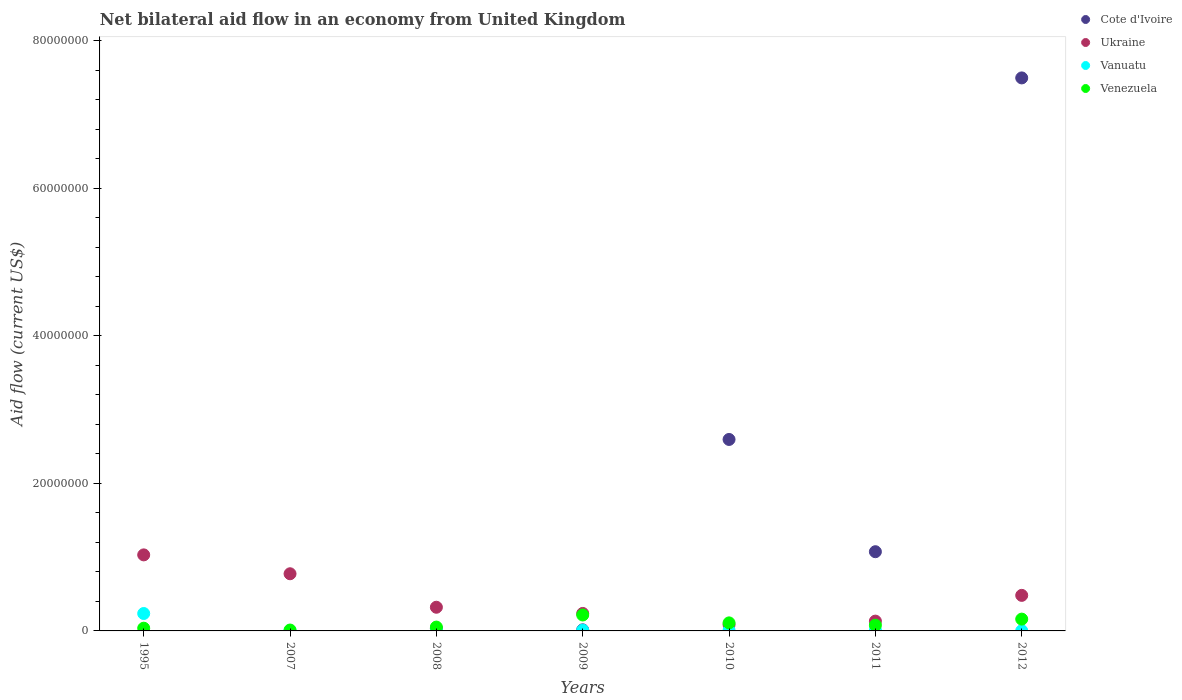How many different coloured dotlines are there?
Offer a terse response. 4. What is the net bilateral aid flow in Venezuela in 2009?
Make the answer very short. 2.16e+06. Across all years, what is the maximum net bilateral aid flow in Ukraine?
Your answer should be compact. 1.03e+07. In which year was the net bilateral aid flow in Cote d'Ivoire maximum?
Ensure brevity in your answer.  2012. What is the total net bilateral aid flow in Venezuela in the graph?
Give a very brief answer. 6.64e+06. What is the difference between the net bilateral aid flow in Venezuela in 2007 and that in 2009?
Offer a terse response. -2.04e+06. What is the difference between the net bilateral aid flow in Vanuatu in 1995 and the net bilateral aid flow in Ukraine in 2012?
Offer a terse response. -2.46e+06. What is the average net bilateral aid flow in Venezuela per year?
Your answer should be very brief. 9.49e+05. In the year 1995, what is the difference between the net bilateral aid flow in Venezuela and net bilateral aid flow in Ukraine?
Offer a very short reply. -9.94e+06. In how many years, is the net bilateral aid flow in Cote d'Ivoire greater than 56000000 US$?
Provide a short and direct response. 1. What is the ratio of the net bilateral aid flow in Venezuela in 1995 to that in 2011?
Provide a succinct answer. 0.47. What is the difference between the highest and the second highest net bilateral aid flow in Venezuela?
Your answer should be very brief. 5.60e+05. What is the difference between the highest and the lowest net bilateral aid flow in Vanuatu?
Your answer should be very brief. 2.33e+06. In how many years, is the net bilateral aid flow in Cote d'Ivoire greater than the average net bilateral aid flow in Cote d'Ivoire taken over all years?
Ensure brevity in your answer.  2. Is the sum of the net bilateral aid flow in Vanuatu in 2009 and 2012 greater than the maximum net bilateral aid flow in Cote d'Ivoire across all years?
Keep it short and to the point. No. Is it the case that in every year, the sum of the net bilateral aid flow in Cote d'Ivoire and net bilateral aid flow in Vanuatu  is greater than the sum of net bilateral aid flow in Ukraine and net bilateral aid flow in Venezuela?
Keep it short and to the point. No. Is the net bilateral aid flow in Ukraine strictly less than the net bilateral aid flow in Venezuela over the years?
Offer a terse response. No. How many dotlines are there?
Provide a succinct answer. 4. How many years are there in the graph?
Offer a terse response. 7. What is the difference between two consecutive major ticks on the Y-axis?
Your answer should be compact. 2.00e+07. Are the values on the major ticks of Y-axis written in scientific E-notation?
Provide a short and direct response. No. How many legend labels are there?
Ensure brevity in your answer.  4. How are the legend labels stacked?
Give a very brief answer. Vertical. What is the title of the graph?
Ensure brevity in your answer.  Net bilateral aid flow in an economy from United Kingdom. Does "Macedonia" appear as one of the legend labels in the graph?
Your answer should be compact. No. What is the label or title of the X-axis?
Give a very brief answer. Years. What is the label or title of the Y-axis?
Give a very brief answer. Aid flow (current US$). What is the Aid flow (current US$) of Ukraine in 1995?
Provide a short and direct response. 1.03e+07. What is the Aid flow (current US$) in Vanuatu in 1995?
Provide a short and direct response. 2.36e+06. What is the Aid flow (current US$) of Venezuela in 1995?
Your answer should be very brief. 3.70e+05. What is the Aid flow (current US$) in Cote d'Ivoire in 2007?
Your answer should be compact. 0. What is the Aid flow (current US$) in Ukraine in 2007?
Your answer should be very brief. 7.75e+06. What is the Aid flow (current US$) in Vanuatu in 2007?
Ensure brevity in your answer.  4.00e+04. What is the Aid flow (current US$) of Venezuela in 2007?
Ensure brevity in your answer.  1.20e+05. What is the Aid flow (current US$) in Ukraine in 2008?
Make the answer very short. 3.21e+06. What is the Aid flow (current US$) in Vanuatu in 2008?
Offer a very short reply. 9.00e+04. What is the Aid flow (current US$) of Venezuela in 2008?
Offer a very short reply. 5.20e+05. What is the Aid flow (current US$) in Cote d'Ivoire in 2009?
Keep it short and to the point. 1.50e+05. What is the Aid flow (current US$) in Ukraine in 2009?
Your answer should be compact. 2.37e+06. What is the Aid flow (current US$) of Vanuatu in 2009?
Ensure brevity in your answer.  1.00e+05. What is the Aid flow (current US$) in Venezuela in 2009?
Make the answer very short. 2.16e+06. What is the Aid flow (current US$) in Cote d'Ivoire in 2010?
Keep it short and to the point. 2.60e+07. What is the Aid flow (current US$) of Ukraine in 2010?
Your answer should be very brief. 8.40e+05. What is the Aid flow (current US$) of Vanuatu in 2010?
Keep it short and to the point. 9.00e+04. What is the Aid flow (current US$) of Venezuela in 2010?
Your answer should be very brief. 1.09e+06. What is the Aid flow (current US$) of Cote d'Ivoire in 2011?
Provide a succinct answer. 1.07e+07. What is the Aid flow (current US$) of Ukraine in 2011?
Ensure brevity in your answer.  1.33e+06. What is the Aid flow (current US$) of Vanuatu in 2011?
Your answer should be compact. 1.10e+05. What is the Aid flow (current US$) of Venezuela in 2011?
Provide a succinct answer. 7.80e+05. What is the Aid flow (current US$) in Cote d'Ivoire in 2012?
Offer a very short reply. 7.50e+07. What is the Aid flow (current US$) in Ukraine in 2012?
Ensure brevity in your answer.  4.82e+06. What is the Aid flow (current US$) in Vanuatu in 2012?
Your answer should be compact. 3.00e+04. What is the Aid flow (current US$) of Venezuela in 2012?
Your response must be concise. 1.60e+06. Across all years, what is the maximum Aid flow (current US$) of Cote d'Ivoire?
Your answer should be compact. 7.50e+07. Across all years, what is the maximum Aid flow (current US$) of Ukraine?
Offer a very short reply. 1.03e+07. Across all years, what is the maximum Aid flow (current US$) in Vanuatu?
Your response must be concise. 2.36e+06. Across all years, what is the maximum Aid flow (current US$) of Venezuela?
Make the answer very short. 2.16e+06. Across all years, what is the minimum Aid flow (current US$) of Ukraine?
Give a very brief answer. 8.40e+05. Across all years, what is the minimum Aid flow (current US$) of Venezuela?
Your response must be concise. 1.20e+05. What is the total Aid flow (current US$) in Cote d'Ivoire in the graph?
Keep it short and to the point. 1.12e+08. What is the total Aid flow (current US$) in Ukraine in the graph?
Keep it short and to the point. 3.06e+07. What is the total Aid flow (current US$) in Vanuatu in the graph?
Give a very brief answer. 2.82e+06. What is the total Aid flow (current US$) in Venezuela in the graph?
Provide a short and direct response. 6.64e+06. What is the difference between the Aid flow (current US$) of Ukraine in 1995 and that in 2007?
Ensure brevity in your answer.  2.56e+06. What is the difference between the Aid flow (current US$) in Vanuatu in 1995 and that in 2007?
Offer a terse response. 2.32e+06. What is the difference between the Aid flow (current US$) in Venezuela in 1995 and that in 2007?
Provide a short and direct response. 2.50e+05. What is the difference between the Aid flow (current US$) of Ukraine in 1995 and that in 2008?
Your answer should be very brief. 7.10e+06. What is the difference between the Aid flow (current US$) in Vanuatu in 1995 and that in 2008?
Your answer should be very brief. 2.27e+06. What is the difference between the Aid flow (current US$) in Ukraine in 1995 and that in 2009?
Your response must be concise. 7.94e+06. What is the difference between the Aid flow (current US$) in Vanuatu in 1995 and that in 2009?
Provide a short and direct response. 2.26e+06. What is the difference between the Aid flow (current US$) of Venezuela in 1995 and that in 2009?
Offer a very short reply. -1.79e+06. What is the difference between the Aid flow (current US$) in Ukraine in 1995 and that in 2010?
Provide a succinct answer. 9.47e+06. What is the difference between the Aid flow (current US$) in Vanuatu in 1995 and that in 2010?
Provide a short and direct response. 2.27e+06. What is the difference between the Aid flow (current US$) of Venezuela in 1995 and that in 2010?
Keep it short and to the point. -7.20e+05. What is the difference between the Aid flow (current US$) in Ukraine in 1995 and that in 2011?
Offer a terse response. 8.98e+06. What is the difference between the Aid flow (current US$) in Vanuatu in 1995 and that in 2011?
Keep it short and to the point. 2.25e+06. What is the difference between the Aid flow (current US$) of Venezuela in 1995 and that in 2011?
Offer a very short reply. -4.10e+05. What is the difference between the Aid flow (current US$) in Ukraine in 1995 and that in 2012?
Offer a very short reply. 5.49e+06. What is the difference between the Aid flow (current US$) of Vanuatu in 1995 and that in 2012?
Offer a terse response. 2.33e+06. What is the difference between the Aid flow (current US$) of Venezuela in 1995 and that in 2012?
Offer a very short reply. -1.23e+06. What is the difference between the Aid flow (current US$) in Ukraine in 2007 and that in 2008?
Offer a very short reply. 4.54e+06. What is the difference between the Aid flow (current US$) in Vanuatu in 2007 and that in 2008?
Make the answer very short. -5.00e+04. What is the difference between the Aid flow (current US$) of Venezuela in 2007 and that in 2008?
Offer a very short reply. -4.00e+05. What is the difference between the Aid flow (current US$) of Ukraine in 2007 and that in 2009?
Your answer should be compact. 5.38e+06. What is the difference between the Aid flow (current US$) of Vanuatu in 2007 and that in 2009?
Offer a very short reply. -6.00e+04. What is the difference between the Aid flow (current US$) of Venezuela in 2007 and that in 2009?
Your response must be concise. -2.04e+06. What is the difference between the Aid flow (current US$) of Ukraine in 2007 and that in 2010?
Your response must be concise. 6.91e+06. What is the difference between the Aid flow (current US$) of Venezuela in 2007 and that in 2010?
Your answer should be very brief. -9.70e+05. What is the difference between the Aid flow (current US$) in Ukraine in 2007 and that in 2011?
Provide a succinct answer. 6.42e+06. What is the difference between the Aid flow (current US$) of Vanuatu in 2007 and that in 2011?
Provide a succinct answer. -7.00e+04. What is the difference between the Aid flow (current US$) of Venezuela in 2007 and that in 2011?
Offer a terse response. -6.60e+05. What is the difference between the Aid flow (current US$) of Ukraine in 2007 and that in 2012?
Offer a very short reply. 2.93e+06. What is the difference between the Aid flow (current US$) of Venezuela in 2007 and that in 2012?
Make the answer very short. -1.48e+06. What is the difference between the Aid flow (current US$) of Ukraine in 2008 and that in 2009?
Ensure brevity in your answer.  8.40e+05. What is the difference between the Aid flow (current US$) in Venezuela in 2008 and that in 2009?
Your response must be concise. -1.64e+06. What is the difference between the Aid flow (current US$) of Cote d'Ivoire in 2008 and that in 2010?
Your response must be concise. -2.56e+07. What is the difference between the Aid flow (current US$) in Ukraine in 2008 and that in 2010?
Ensure brevity in your answer.  2.37e+06. What is the difference between the Aid flow (current US$) of Vanuatu in 2008 and that in 2010?
Make the answer very short. 0. What is the difference between the Aid flow (current US$) in Venezuela in 2008 and that in 2010?
Provide a short and direct response. -5.70e+05. What is the difference between the Aid flow (current US$) in Cote d'Ivoire in 2008 and that in 2011?
Give a very brief answer. -1.04e+07. What is the difference between the Aid flow (current US$) in Ukraine in 2008 and that in 2011?
Make the answer very short. 1.88e+06. What is the difference between the Aid flow (current US$) in Vanuatu in 2008 and that in 2011?
Your answer should be compact. -2.00e+04. What is the difference between the Aid flow (current US$) of Venezuela in 2008 and that in 2011?
Keep it short and to the point. -2.60e+05. What is the difference between the Aid flow (current US$) of Cote d'Ivoire in 2008 and that in 2012?
Offer a very short reply. -7.46e+07. What is the difference between the Aid flow (current US$) of Ukraine in 2008 and that in 2012?
Provide a succinct answer. -1.61e+06. What is the difference between the Aid flow (current US$) in Venezuela in 2008 and that in 2012?
Provide a succinct answer. -1.08e+06. What is the difference between the Aid flow (current US$) in Cote d'Ivoire in 2009 and that in 2010?
Your answer should be very brief. -2.58e+07. What is the difference between the Aid flow (current US$) in Ukraine in 2009 and that in 2010?
Ensure brevity in your answer.  1.53e+06. What is the difference between the Aid flow (current US$) in Vanuatu in 2009 and that in 2010?
Offer a very short reply. 10000. What is the difference between the Aid flow (current US$) of Venezuela in 2009 and that in 2010?
Offer a terse response. 1.07e+06. What is the difference between the Aid flow (current US$) of Cote d'Ivoire in 2009 and that in 2011?
Give a very brief answer. -1.06e+07. What is the difference between the Aid flow (current US$) in Ukraine in 2009 and that in 2011?
Your response must be concise. 1.04e+06. What is the difference between the Aid flow (current US$) in Vanuatu in 2009 and that in 2011?
Your answer should be compact. -10000. What is the difference between the Aid flow (current US$) of Venezuela in 2009 and that in 2011?
Provide a succinct answer. 1.38e+06. What is the difference between the Aid flow (current US$) in Cote d'Ivoire in 2009 and that in 2012?
Your answer should be compact. -7.48e+07. What is the difference between the Aid flow (current US$) of Ukraine in 2009 and that in 2012?
Offer a terse response. -2.45e+06. What is the difference between the Aid flow (current US$) in Vanuatu in 2009 and that in 2012?
Ensure brevity in your answer.  7.00e+04. What is the difference between the Aid flow (current US$) of Venezuela in 2009 and that in 2012?
Keep it short and to the point. 5.60e+05. What is the difference between the Aid flow (current US$) in Cote d'Ivoire in 2010 and that in 2011?
Provide a succinct answer. 1.52e+07. What is the difference between the Aid flow (current US$) in Ukraine in 2010 and that in 2011?
Provide a succinct answer. -4.90e+05. What is the difference between the Aid flow (current US$) in Cote d'Ivoire in 2010 and that in 2012?
Ensure brevity in your answer.  -4.90e+07. What is the difference between the Aid flow (current US$) of Ukraine in 2010 and that in 2012?
Provide a short and direct response. -3.98e+06. What is the difference between the Aid flow (current US$) of Venezuela in 2010 and that in 2012?
Offer a very short reply. -5.10e+05. What is the difference between the Aid flow (current US$) of Cote d'Ivoire in 2011 and that in 2012?
Provide a short and direct response. -6.42e+07. What is the difference between the Aid flow (current US$) of Ukraine in 2011 and that in 2012?
Your response must be concise. -3.49e+06. What is the difference between the Aid flow (current US$) in Vanuatu in 2011 and that in 2012?
Give a very brief answer. 8.00e+04. What is the difference between the Aid flow (current US$) in Venezuela in 2011 and that in 2012?
Offer a terse response. -8.20e+05. What is the difference between the Aid flow (current US$) in Ukraine in 1995 and the Aid flow (current US$) in Vanuatu in 2007?
Your response must be concise. 1.03e+07. What is the difference between the Aid flow (current US$) of Ukraine in 1995 and the Aid flow (current US$) of Venezuela in 2007?
Your answer should be compact. 1.02e+07. What is the difference between the Aid flow (current US$) in Vanuatu in 1995 and the Aid flow (current US$) in Venezuela in 2007?
Keep it short and to the point. 2.24e+06. What is the difference between the Aid flow (current US$) in Ukraine in 1995 and the Aid flow (current US$) in Vanuatu in 2008?
Ensure brevity in your answer.  1.02e+07. What is the difference between the Aid flow (current US$) in Ukraine in 1995 and the Aid flow (current US$) in Venezuela in 2008?
Your answer should be compact. 9.79e+06. What is the difference between the Aid flow (current US$) of Vanuatu in 1995 and the Aid flow (current US$) of Venezuela in 2008?
Offer a very short reply. 1.84e+06. What is the difference between the Aid flow (current US$) in Ukraine in 1995 and the Aid flow (current US$) in Vanuatu in 2009?
Give a very brief answer. 1.02e+07. What is the difference between the Aid flow (current US$) in Ukraine in 1995 and the Aid flow (current US$) in Venezuela in 2009?
Give a very brief answer. 8.15e+06. What is the difference between the Aid flow (current US$) of Vanuatu in 1995 and the Aid flow (current US$) of Venezuela in 2009?
Offer a terse response. 2.00e+05. What is the difference between the Aid flow (current US$) of Ukraine in 1995 and the Aid flow (current US$) of Vanuatu in 2010?
Your response must be concise. 1.02e+07. What is the difference between the Aid flow (current US$) in Ukraine in 1995 and the Aid flow (current US$) in Venezuela in 2010?
Your answer should be very brief. 9.22e+06. What is the difference between the Aid flow (current US$) in Vanuatu in 1995 and the Aid flow (current US$) in Venezuela in 2010?
Keep it short and to the point. 1.27e+06. What is the difference between the Aid flow (current US$) in Ukraine in 1995 and the Aid flow (current US$) in Vanuatu in 2011?
Make the answer very short. 1.02e+07. What is the difference between the Aid flow (current US$) of Ukraine in 1995 and the Aid flow (current US$) of Venezuela in 2011?
Your response must be concise. 9.53e+06. What is the difference between the Aid flow (current US$) in Vanuatu in 1995 and the Aid flow (current US$) in Venezuela in 2011?
Your response must be concise. 1.58e+06. What is the difference between the Aid flow (current US$) of Ukraine in 1995 and the Aid flow (current US$) of Vanuatu in 2012?
Make the answer very short. 1.03e+07. What is the difference between the Aid flow (current US$) in Ukraine in 1995 and the Aid flow (current US$) in Venezuela in 2012?
Provide a short and direct response. 8.71e+06. What is the difference between the Aid flow (current US$) in Vanuatu in 1995 and the Aid flow (current US$) in Venezuela in 2012?
Offer a very short reply. 7.60e+05. What is the difference between the Aid flow (current US$) in Ukraine in 2007 and the Aid flow (current US$) in Vanuatu in 2008?
Your answer should be compact. 7.66e+06. What is the difference between the Aid flow (current US$) of Ukraine in 2007 and the Aid flow (current US$) of Venezuela in 2008?
Keep it short and to the point. 7.23e+06. What is the difference between the Aid flow (current US$) in Vanuatu in 2007 and the Aid flow (current US$) in Venezuela in 2008?
Provide a short and direct response. -4.80e+05. What is the difference between the Aid flow (current US$) of Ukraine in 2007 and the Aid flow (current US$) of Vanuatu in 2009?
Provide a short and direct response. 7.65e+06. What is the difference between the Aid flow (current US$) of Ukraine in 2007 and the Aid flow (current US$) of Venezuela in 2009?
Offer a very short reply. 5.59e+06. What is the difference between the Aid flow (current US$) in Vanuatu in 2007 and the Aid flow (current US$) in Venezuela in 2009?
Offer a terse response. -2.12e+06. What is the difference between the Aid flow (current US$) of Ukraine in 2007 and the Aid flow (current US$) of Vanuatu in 2010?
Provide a succinct answer. 7.66e+06. What is the difference between the Aid flow (current US$) of Ukraine in 2007 and the Aid flow (current US$) of Venezuela in 2010?
Your response must be concise. 6.66e+06. What is the difference between the Aid flow (current US$) of Vanuatu in 2007 and the Aid flow (current US$) of Venezuela in 2010?
Your answer should be very brief. -1.05e+06. What is the difference between the Aid flow (current US$) in Ukraine in 2007 and the Aid flow (current US$) in Vanuatu in 2011?
Provide a succinct answer. 7.64e+06. What is the difference between the Aid flow (current US$) in Ukraine in 2007 and the Aid flow (current US$) in Venezuela in 2011?
Your response must be concise. 6.97e+06. What is the difference between the Aid flow (current US$) of Vanuatu in 2007 and the Aid flow (current US$) of Venezuela in 2011?
Offer a very short reply. -7.40e+05. What is the difference between the Aid flow (current US$) of Ukraine in 2007 and the Aid flow (current US$) of Vanuatu in 2012?
Give a very brief answer. 7.72e+06. What is the difference between the Aid flow (current US$) in Ukraine in 2007 and the Aid flow (current US$) in Venezuela in 2012?
Your answer should be very brief. 6.15e+06. What is the difference between the Aid flow (current US$) of Vanuatu in 2007 and the Aid flow (current US$) of Venezuela in 2012?
Your answer should be compact. -1.56e+06. What is the difference between the Aid flow (current US$) of Cote d'Ivoire in 2008 and the Aid flow (current US$) of Ukraine in 2009?
Your response must be concise. -2.03e+06. What is the difference between the Aid flow (current US$) of Cote d'Ivoire in 2008 and the Aid flow (current US$) of Venezuela in 2009?
Your answer should be compact. -1.82e+06. What is the difference between the Aid flow (current US$) in Ukraine in 2008 and the Aid flow (current US$) in Vanuatu in 2009?
Ensure brevity in your answer.  3.11e+06. What is the difference between the Aid flow (current US$) of Ukraine in 2008 and the Aid flow (current US$) of Venezuela in 2009?
Your response must be concise. 1.05e+06. What is the difference between the Aid flow (current US$) of Vanuatu in 2008 and the Aid flow (current US$) of Venezuela in 2009?
Your answer should be very brief. -2.07e+06. What is the difference between the Aid flow (current US$) in Cote d'Ivoire in 2008 and the Aid flow (current US$) in Ukraine in 2010?
Ensure brevity in your answer.  -5.00e+05. What is the difference between the Aid flow (current US$) of Cote d'Ivoire in 2008 and the Aid flow (current US$) of Venezuela in 2010?
Your answer should be compact. -7.50e+05. What is the difference between the Aid flow (current US$) of Ukraine in 2008 and the Aid flow (current US$) of Vanuatu in 2010?
Offer a terse response. 3.12e+06. What is the difference between the Aid flow (current US$) of Ukraine in 2008 and the Aid flow (current US$) of Venezuela in 2010?
Provide a short and direct response. 2.12e+06. What is the difference between the Aid flow (current US$) in Vanuatu in 2008 and the Aid flow (current US$) in Venezuela in 2010?
Provide a short and direct response. -1.00e+06. What is the difference between the Aid flow (current US$) in Cote d'Ivoire in 2008 and the Aid flow (current US$) in Ukraine in 2011?
Offer a very short reply. -9.90e+05. What is the difference between the Aid flow (current US$) in Cote d'Ivoire in 2008 and the Aid flow (current US$) in Venezuela in 2011?
Offer a terse response. -4.40e+05. What is the difference between the Aid flow (current US$) of Ukraine in 2008 and the Aid flow (current US$) of Vanuatu in 2011?
Make the answer very short. 3.10e+06. What is the difference between the Aid flow (current US$) of Ukraine in 2008 and the Aid flow (current US$) of Venezuela in 2011?
Provide a short and direct response. 2.43e+06. What is the difference between the Aid flow (current US$) of Vanuatu in 2008 and the Aid flow (current US$) of Venezuela in 2011?
Provide a short and direct response. -6.90e+05. What is the difference between the Aid flow (current US$) in Cote d'Ivoire in 2008 and the Aid flow (current US$) in Ukraine in 2012?
Keep it short and to the point. -4.48e+06. What is the difference between the Aid flow (current US$) of Cote d'Ivoire in 2008 and the Aid flow (current US$) of Venezuela in 2012?
Give a very brief answer. -1.26e+06. What is the difference between the Aid flow (current US$) in Ukraine in 2008 and the Aid flow (current US$) in Vanuatu in 2012?
Your answer should be compact. 3.18e+06. What is the difference between the Aid flow (current US$) in Ukraine in 2008 and the Aid flow (current US$) in Venezuela in 2012?
Give a very brief answer. 1.61e+06. What is the difference between the Aid flow (current US$) in Vanuatu in 2008 and the Aid flow (current US$) in Venezuela in 2012?
Give a very brief answer. -1.51e+06. What is the difference between the Aid flow (current US$) in Cote d'Ivoire in 2009 and the Aid flow (current US$) in Ukraine in 2010?
Provide a succinct answer. -6.90e+05. What is the difference between the Aid flow (current US$) of Cote d'Ivoire in 2009 and the Aid flow (current US$) of Vanuatu in 2010?
Give a very brief answer. 6.00e+04. What is the difference between the Aid flow (current US$) of Cote d'Ivoire in 2009 and the Aid flow (current US$) of Venezuela in 2010?
Offer a very short reply. -9.40e+05. What is the difference between the Aid flow (current US$) of Ukraine in 2009 and the Aid flow (current US$) of Vanuatu in 2010?
Ensure brevity in your answer.  2.28e+06. What is the difference between the Aid flow (current US$) of Ukraine in 2009 and the Aid flow (current US$) of Venezuela in 2010?
Your response must be concise. 1.28e+06. What is the difference between the Aid flow (current US$) of Vanuatu in 2009 and the Aid flow (current US$) of Venezuela in 2010?
Your answer should be compact. -9.90e+05. What is the difference between the Aid flow (current US$) of Cote d'Ivoire in 2009 and the Aid flow (current US$) of Ukraine in 2011?
Provide a succinct answer. -1.18e+06. What is the difference between the Aid flow (current US$) of Cote d'Ivoire in 2009 and the Aid flow (current US$) of Vanuatu in 2011?
Your response must be concise. 4.00e+04. What is the difference between the Aid flow (current US$) of Cote d'Ivoire in 2009 and the Aid flow (current US$) of Venezuela in 2011?
Provide a succinct answer. -6.30e+05. What is the difference between the Aid flow (current US$) in Ukraine in 2009 and the Aid flow (current US$) in Vanuatu in 2011?
Your answer should be compact. 2.26e+06. What is the difference between the Aid flow (current US$) of Ukraine in 2009 and the Aid flow (current US$) of Venezuela in 2011?
Provide a short and direct response. 1.59e+06. What is the difference between the Aid flow (current US$) of Vanuatu in 2009 and the Aid flow (current US$) of Venezuela in 2011?
Provide a succinct answer. -6.80e+05. What is the difference between the Aid flow (current US$) of Cote d'Ivoire in 2009 and the Aid flow (current US$) of Ukraine in 2012?
Your answer should be compact. -4.67e+06. What is the difference between the Aid flow (current US$) in Cote d'Ivoire in 2009 and the Aid flow (current US$) in Vanuatu in 2012?
Provide a short and direct response. 1.20e+05. What is the difference between the Aid flow (current US$) in Cote d'Ivoire in 2009 and the Aid flow (current US$) in Venezuela in 2012?
Your answer should be very brief. -1.45e+06. What is the difference between the Aid flow (current US$) in Ukraine in 2009 and the Aid flow (current US$) in Vanuatu in 2012?
Make the answer very short. 2.34e+06. What is the difference between the Aid flow (current US$) of Ukraine in 2009 and the Aid flow (current US$) of Venezuela in 2012?
Provide a succinct answer. 7.70e+05. What is the difference between the Aid flow (current US$) in Vanuatu in 2009 and the Aid flow (current US$) in Venezuela in 2012?
Your answer should be very brief. -1.50e+06. What is the difference between the Aid flow (current US$) in Cote d'Ivoire in 2010 and the Aid flow (current US$) in Ukraine in 2011?
Offer a terse response. 2.46e+07. What is the difference between the Aid flow (current US$) in Cote d'Ivoire in 2010 and the Aid flow (current US$) in Vanuatu in 2011?
Your answer should be compact. 2.58e+07. What is the difference between the Aid flow (current US$) in Cote d'Ivoire in 2010 and the Aid flow (current US$) in Venezuela in 2011?
Provide a succinct answer. 2.52e+07. What is the difference between the Aid flow (current US$) of Ukraine in 2010 and the Aid flow (current US$) of Vanuatu in 2011?
Make the answer very short. 7.30e+05. What is the difference between the Aid flow (current US$) in Vanuatu in 2010 and the Aid flow (current US$) in Venezuela in 2011?
Offer a very short reply. -6.90e+05. What is the difference between the Aid flow (current US$) of Cote d'Ivoire in 2010 and the Aid flow (current US$) of Ukraine in 2012?
Your answer should be compact. 2.11e+07. What is the difference between the Aid flow (current US$) in Cote d'Ivoire in 2010 and the Aid flow (current US$) in Vanuatu in 2012?
Offer a very short reply. 2.59e+07. What is the difference between the Aid flow (current US$) in Cote d'Ivoire in 2010 and the Aid flow (current US$) in Venezuela in 2012?
Give a very brief answer. 2.44e+07. What is the difference between the Aid flow (current US$) in Ukraine in 2010 and the Aid flow (current US$) in Vanuatu in 2012?
Provide a short and direct response. 8.10e+05. What is the difference between the Aid flow (current US$) in Ukraine in 2010 and the Aid flow (current US$) in Venezuela in 2012?
Your response must be concise. -7.60e+05. What is the difference between the Aid flow (current US$) in Vanuatu in 2010 and the Aid flow (current US$) in Venezuela in 2012?
Ensure brevity in your answer.  -1.51e+06. What is the difference between the Aid flow (current US$) in Cote d'Ivoire in 2011 and the Aid flow (current US$) in Ukraine in 2012?
Your answer should be compact. 5.92e+06. What is the difference between the Aid flow (current US$) in Cote d'Ivoire in 2011 and the Aid flow (current US$) in Vanuatu in 2012?
Offer a terse response. 1.07e+07. What is the difference between the Aid flow (current US$) in Cote d'Ivoire in 2011 and the Aid flow (current US$) in Venezuela in 2012?
Ensure brevity in your answer.  9.14e+06. What is the difference between the Aid flow (current US$) in Ukraine in 2011 and the Aid flow (current US$) in Vanuatu in 2012?
Ensure brevity in your answer.  1.30e+06. What is the difference between the Aid flow (current US$) in Vanuatu in 2011 and the Aid flow (current US$) in Venezuela in 2012?
Give a very brief answer. -1.49e+06. What is the average Aid flow (current US$) in Cote d'Ivoire per year?
Ensure brevity in your answer.  1.60e+07. What is the average Aid flow (current US$) in Ukraine per year?
Give a very brief answer. 4.38e+06. What is the average Aid flow (current US$) in Vanuatu per year?
Offer a terse response. 4.03e+05. What is the average Aid flow (current US$) in Venezuela per year?
Keep it short and to the point. 9.49e+05. In the year 1995, what is the difference between the Aid flow (current US$) of Ukraine and Aid flow (current US$) of Vanuatu?
Ensure brevity in your answer.  7.95e+06. In the year 1995, what is the difference between the Aid flow (current US$) in Ukraine and Aid flow (current US$) in Venezuela?
Provide a short and direct response. 9.94e+06. In the year 1995, what is the difference between the Aid flow (current US$) of Vanuatu and Aid flow (current US$) of Venezuela?
Offer a very short reply. 1.99e+06. In the year 2007, what is the difference between the Aid flow (current US$) of Ukraine and Aid flow (current US$) of Vanuatu?
Provide a succinct answer. 7.71e+06. In the year 2007, what is the difference between the Aid flow (current US$) in Ukraine and Aid flow (current US$) in Venezuela?
Your answer should be compact. 7.63e+06. In the year 2007, what is the difference between the Aid flow (current US$) of Vanuatu and Aid flow (current US$) of Venezuela?
Make the answer very short. -8.00e+04. In the year 2008, what is the difference between the Aid flow (current US$) of Cote d'Ivoire and Aid flow (current US$) of Ukraine?
Make the answer very short. -2.87e+06. In the year 2008, what is the difference between the Aid flow (current US$) in Cote d'Ivoire and Aid flow (current US$) in Venezuela?
Provide a short and direct response. -1.80e+05. In the year 2008, what is the difference between the Aid flow (current US$) of Ukraine and Aid flow (current US$) of Vanuatu?
Provide a succinct answer. 3.12e+06. In the year 2008, what is the difference between the Aid flow (current US$) of Ukraine and Aid flow (current US$) of Venezuela?
Offer a very short reply. 2.69e+06. In the year 2008, what is the difference between the Aid flow (current US$) in Vanuatu and Aid flow (current US$) in Venezuela?
Your answer should be compact. -4.30e+05. In the year 2009, what is the difference between the Aid flow (current US$) in Cote d'Ivoire and Aid flow (current US$) in Ukraine?
Give a very brief answer. -2.22e+06. In the year 2009, what is the difference between the Aid flow (current US$) of Cote d'Ivoire and Aid flow (current US$) of Vanuatu?
Offer a terse response. 5.00e+04. In the year 2009, what is the difference between the Aid flow (current US$) of Cote d'Ivoire and Aid flow (current US$) of Venezuela?
Give a very brief answer. -2.01e+06. In the year 2009, what is the difference between the Aid flow (current US$) of Ukraine and Aid flow (current US$) of Vanuatu?
Your answer should be very brief. 2.27e+06. In the year 2009, what is the difference between the Aid flow (current US$) of Ukraine and Aid flow (current US$) of Venezuela?
Ensure brevity in your answer.  2.10e+05. In the year 2009, what is the difference between the Aid flow (current US$) of Vanuatu and Aid flow (current US$) of Venezuela?
Your answer should be very brief. -2.06e+06. In the year 2010, what is the difference between the Aid flow (current US$) in Cote d'Ivoire and Aid flow (current US$) in Ukraine?
Your answer should be very brief. 2.51e+07. In the year 2010, what is the difference between the Aid flow (current US$) of Cote d'Ivoire and Aid flow (current US$) of Vanuatu?
Your answer should be compact. 2.59e+07. In the year 2010, what is the difference between the Aid flow (current US$) in Cote d'Ivoire and Aid flow (current US$) in Venezuela?
Your response must be concise. 2.49e+07. In the year 2010, what is the difference between the Aid flow (current US$) of Ukraine and Aid flow (current US$) of Vanuatu?
Your response must be concise. 7.50e+05. In the year 2010, what is the difference between the Aid flow (current US$) in Ukraine and Aid flow (current US$) in Venezuela?
Make the answer very short. -2.50e+05. In the year 2011, what is the difference between the Aid flow (current US$) of Cote d'Ivoire and Aid flow (current US$) of Ukraine?
Offer a very short reply. 9.41e+06. In the year 2011, what is the difference between the Aid flow (current US$) of Cote d'Ivoire and Aid flow (current US$) of Vanuatu?
Give a very brief answer. 1.06e+07. In the year 2011, what is the difference between the Aid flow (current US$) of Cote d'Ivoire and Aid flow (current US$) of Venezuela?
Your answer should be very brief. 9.96e+06. In the year 2011, what is the difference between the Aid flow (current US$) of Ukraine and Aid flow (current US$) of Vanuatu?
Provide a succinct answer. 1.22e+06. In the year 2011, what is the difference between the Aid flow (current US$) in Vanuatu and Aid flow (current US$) in Venezuela?
Your answer should be compact. -6.70e+05. In the year 2012, what is the difference between the Aid flow (current US$) of Cote d'Ivoire and Aid flow (current US$) of Ukraine?
Ensure brevity in your answer.  7.02e+07. In the year 2012, what is the difference between the Aid flow (current US$) of Cote d'Ivoire and Aid flow (current US$) of Vanuatu?
Keep it short and to the point. 7.50e+07. In the year 2012, what is the difference between the Aid flow (current US$) in Cote d'Ivoire and Aid flow (current US$) in Venezuela?
Your answer should be very brief. 7.34e+07. In the year 2012, what is the difference between the Aid flow (current US$) of Ukraine and Aid flow (current US$) of Vanuatu?
Make the answer very short. 4.79e+06. In the year 2012, what is the difference between the Aid flow (current US$) in Ukraine and Aid flow (current US$) in Venezuela?
Keep it short and to the point. 3.22e+06. In the year 2012, what is the difference between the Aid flow (current US$) in Vanuatu and Aid flow (current US$) in Venezuela?
Your answer should be very brief. -1.57e+06. What is the ratio of the Aid flow (current US$) in Ukraine in 1995 to that in 2007?
Provide a succinct answer. 1.33. What is the ratio of the Aid flow (current US$) of Venezuela in 1995 to that in 2007?
Ensure brevity in your answer.  3.08. What is the ratio of the Aid flow (current US$) in Ukraine in 1995 to that in 2008?
Your response must be concise. 3.21. What is the ratio of the Aid flow (current US$) in Vanuatu in 1995 to that in 2008?
Keep it short and to the point. 26.22. What is the ratio of the Aid flow (current US$) of Venezuela in 1995 to that in 2008?
Your answer should be very brief. 0.71. What is the ratio of the Aid flow (current US$) in Ukraine in 1995 to that in 2009?
Provide a short and direct response. 4.35. What is the ratio of the Aid flow (current US$) of Vanuatu in 1995 to that in 2009?
Your answer should be very brief. 23.6. What is the ratio of the Aid flow (current US$) of Venezuela in 1995 to that in 2009?
Your answer should be very brief. 0.17. What is the ratio of the Aid flow (current US$) in Ukraine in 1995 to that in 2010?
Offer a terse response. 12.27. What is the ratio of the Aid flow (current US$) of Vanuatu in 1995 to that in 2010?
Make the answer very short. 26.22. What is the ratio of the Aid flow (current US$) of Venezuela in 1995 to that in 2010?
Offer a very short reply. 0.34. What is the ratio of the Aid flow (current US$) of Ukraine in 1995 to that in 2011?
Ensure brevity in your answer.  7.75. What is the ratio of the Aid flow (current US$) of Vanuatu in 1995 to that in 2011?
Offer a terse response. 21.45. What is the ratio of the Aid flow (current US$) of Venezuela in 1995 to that in 2011?
Your answer should be compact. 0.47. What is the ratio of the Aid flow (current US$) in Ukraine in 1995 to that in 2012?
Offer a very short reply. 2.14. What is the ratio of the Aid flow (current US$) in Vanuatu in 1995 to that in 2012?
Provide a short and direct response. 78.67. What is the ratio of the Aid flow (current US$) in Venezuela in 1995 to that in 2012?
Give a very brief answer. 0.23. What is the ratio of the Aid flow (current US$) in Ukraine in 2007 to that in 2008?
Ensure brevity in your answer.  2.41. What is the ratio of the Aid flow (current US$) in Vanuatu in 2007 to that in 2008?
Your answer should be compact. 0.44. What is the ratio of the Aid flow (current US$) in Venezuela in 2007 to that in 2008?
Offer a terse response. 0.23. What is the ratio of the Aid flow (current US$) in Ukraine in 2007 to that in 2009?
Provide a succinct answer. 3.27. What is the ratio of the Aid flow (current US$) of Vanuatu in 2007 to that in 2009?
Make the answer very short. 0.4. What is the ratio of the Aid flow (current US$) of Venezuela in 2007 to that in 2009?
Provide a short and direct response. 0.06. What is the ratio of the Aid flow (current US$) of Ukraine in 2007 to that in 2010?
Offer a terse response. 9.23. What is the ratio of the Aid flow (current US$) in Vanuatu in 2007 to that in 2010?
Keep it short and to the point. 0.44. What is the ratio of the Aid flow (current US$) of Venezuela in 2007 to that in 2010?
Your response must be concise. 0.11. What is the ratio of the Aid flow (current US$) of Ukraine in 2007 to that in 2011?
Your answer should be compact. 5.83. What is the ratio of the Aid flow (current US$) in Vanuatu in 2007 to that in 2011?
Offer a terse response. 0.36. What is the ratio of the Aid flow (current US$) in Venezuela in 2007 to that in 2011?
Give a very brief answer. 0.15. What is the ratio of the Aid flow (current US$) in Ukraine in 2007 to that in 2012?
Give a very brief answer. 1.61. What is the ratio of the Aid flow (current US$) of Vanuatu in 2007 to that in 2012?
Provide a succinct answer. 1.33. What is the ratio of the Aid flow (current US$) of Venezuela in 2007 to that in 2012?
Give a very brief answer. 0.07. What is the ratio of the Aid flow (current US$) in Cote d'Ivoire in 2008 to that in 2009?
Ensure brevity in your answer.  2.27. What is the ratio of the Aid flow (current US$) in Ukraine in 2008 to that in 2009?
Offer a very short reply. 1.35. What is the ratio of the Aid flow (current US$) of Venezuela in 2008 to that in 2009?
Your response must be concise. 0.24. What is the ratio of the Aid flow (current US$) of Cote d'Ivoire in 2008 to that in 2010?
Give a very brief answer. 0.01. What is the ratio of the Aid flow (current US$) of Ukraine in 2008 to that in 2010?
Your answer should be very brief. 3.82. What is the ratio of the Aid flow (current US$) of Vanuatu in 2008 to that in 2010?
Your response must be concise. 1. What is the ratio of the Aid flow (current US$) of Venezuela in 2008 to that in 2010?
Give a very brief answer. 0.48. What is the ratio of the Aid flow (current US$) in Cote d'Ivoire in 2008 to that in 2011?
Keep it short and to the point. 0.03. What is the ratio of the Aid flow (current US$) in Ukraine in 2008 to that in 2011?
Offer a terse response. 2.41. What is the ratio of the Aid flow (current US$) in Vanuatu in 2008 to that in 2011?
Your answer should be very brief. 0.82. What is the ratio of the Aid flow (current US$) of Cote d'Ivoire in 2008 to that in 2012?
Offer a very short reply. 0. What is the ratio of the Aid flow (current US$) in Ukraine in 2008 to that in 2012?
Offer a terse response. 0.67. What is the ratio of the Aid flow (current US$) of Venezuela in 2008 to that in 2012?
Your answer should be compact. 0.33. What is the ratio of the Aid flow (current US$) in Cote d'Ivoire in 2009 to that in 2010?
Ensure brevity in your answer.  0.01. What is the ratio of the Aid flow (current US$) in Ukraine in 2009 to that in 2010?
Give a very brief answer. 2.82. What is the ratio of the Aid flow (current US$) in Vanuatu in 2009 to that in 2010?
Make the answer very short. 1.11. What is the ratio of the Aid flow (current US$) of Venezuela in 2009 to that in 2010?
Give a very brief answer. 1.98. What is the ratio of the Aid flow (current US$) of Cote d'Ivoire in 2009 to that in 2011?
Give a very brief answer. 0.01. What is the ratio of the Aid flow (current US$) of Ukraine in 2009 to that in 2011?
Your answer should be very brief. 1.78. What is the ratio of the Aid flow (current US$) of Vanuatu in 2009 to that in 2011?
Your answer should be compact. 0.91. What is the ratio of the Aid flow (current US$) of Venezuela in 2009 to that in 2011?
Your answer should be very brief. 2.77. What is the ratio of the Aid flow (current US$) of Cote d'Ivoire in 2009 to that in 2012?
Make the answer very short. 0. What is the ratio of the Aid flow (current US$) in Ukraine in 2009 to that in 2012?
Offer a very short reply. 0.49. What is the ratio of the Aid flow (current US$) in Venezuela in 2009 to that in 2012?
Keep it short and to the point. 1.35. What is the ratio of the Aid flow (current US$) in Cote d'Ivoire in 2010 to that in 2011?
Your answer should be compact. 2.42. What is the ratio of the Aid flow (current US$) in Ukraine in 2010 to that in 2011?
Your answer should be very brief. 0.63. What is the ratio of the Aid flow (current US$) in Vanuatu in 2010 to that in 2011?
Provide a short and direct response. 0.82. What is the ratio of the Aid flow (current US$) in Venezuela in 2010 to that in 2011?
Provide a short and direct response. 1.4. What is the ratio of the Aid flow (current US$) in Cote d'Ivoire in 2010 to that in 2012?
Your response must be concise. 0.35. What is the ratio of the Aid flow (current US$) of Ukraine in 2010 to that in 2012?
Provide a succinct answer. 0.17. What is the ratio of the Aid flow (current US$) of Vanuatu in 2010 to that in 2012?
Provide a short and direct response. 3. What is the ratio of the Aid flow (current US$) in Venezuela in 2010 to that in 2012?
Provide a succinct answer. 0.68. What is the ratio of the Aid flow (current US$) in Cote d'Ivoire in 2011 to that in 2012?
Make the answer very short. 0.14. What is the ratio of the Aid flow (current US$) in Ukraine in 2011 to that in 2012?
Provide a succinct answer. 0.28. What is the ratio of the Aid flow (current US$) of Vanuatu in 2011 to that in 2012?
Ensure brevity in your answer.  3.67. What is the ratio of the Aid flow (current US$) in Venezuela in 2011 to that in 2012?
Provide a short and direct response. 0.49. What is the difference between the highest and the second highest Aid flow (current US$) in Cote d'Ivoire?
Keep it short and to the point. 4.90e+07. What is the difference between the highest and the second highest Aid flow (current US$) of Ukraine?
Make the answer very short. 2.56e+06. What is the difference between the highest and the second highest Aid flow (current US$) in Vanuatu?
Offer a very short reply. 2.25e+06. What is the difference between the highest and the second highest Aid flow (current US$) of Venezuela?
Provide a short and direct response. 5.60e+05. What is the difference between the highest and the lowest Aid flow (current US$) in Cote d'Ivoire?
Ensure brevity in your answer.  7.50e+07. What is the difference between the highest and the lowest Aid flow (current US$) of Ukraine?
Your response must be concise. 9.47e+06. What is the difference between the highest and the lowest Aid flow (current US$) in Vanuatu?
Ensure brevity in your answer.  2.33e+06. What is the difference between the highest and the lowest Aid flow (current US$) in Venezuela?
Make the answer very short. 2.04e+06. 